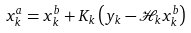Convert formula to latex. <formula><loc_0><loc_0><loc_500><loc_500>x _ { k } ^ { a } = x _ { k } ^ { b } + K _ { k } \left ( y _ { k } - \mathcal { H } _ { k } x _ { k } ^ { b } \right )</formula> 